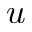Convert formula to latex. <formula><loc_0><loc_0><loc_500><loc_500>u</formula> 